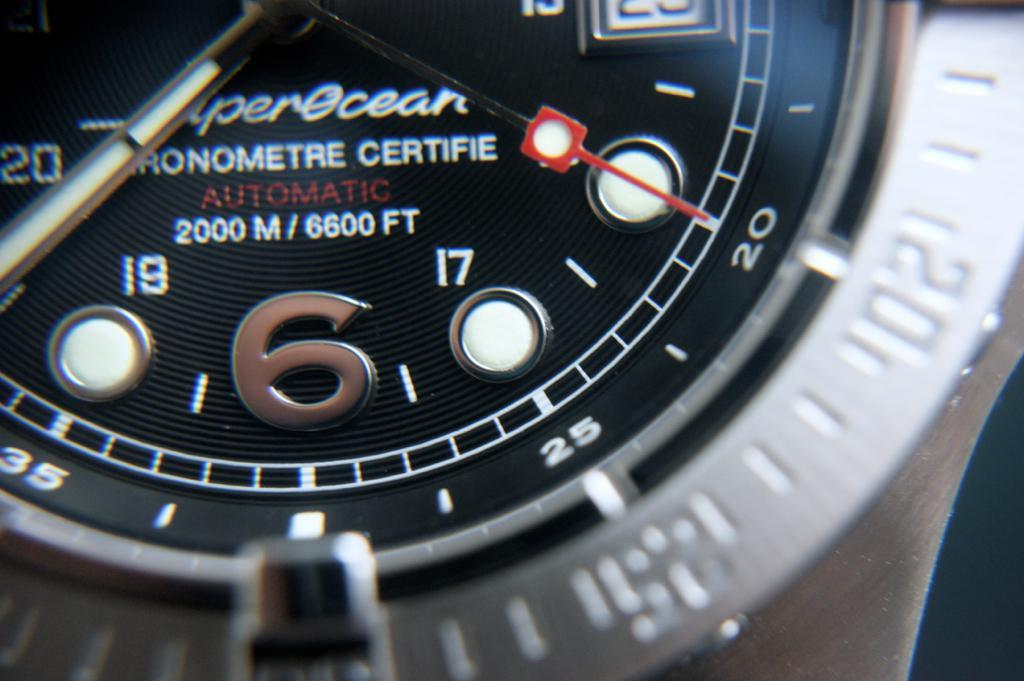<image>
Present a compact description of the photo's key features. A close up picture of a watch that reads AUTOMATIC 2000 M / 6600 FT. 